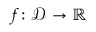<formula> <loc_0><loc_0><loc_500><loc_500>f \colon { \mathcal { D } } \to \mathbb { R }</formula> 